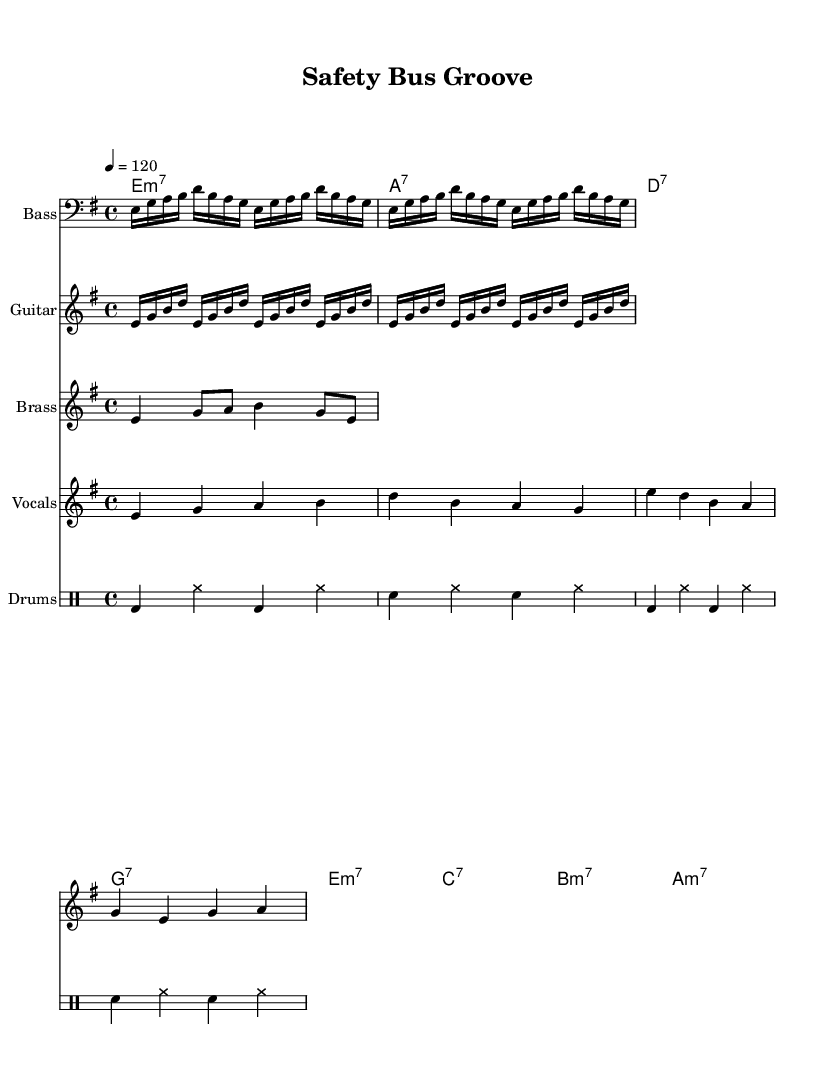What is the key signature of this music? The key signature is E minor, which has one sharp (F#). This can be identified by looking at the key signature indication at the beginning of the score.
Answer: E minor What is the time signature of the piece? The time signature is 4/4, meaning there are four beats in each measure and a quarter note receives one beat. This is indicated at the start of the score in a typical time signature notation.
Answer: 4/4 What is the tempo marking for this piece? The tempo marking is 120 beats per minute, which indicates how fast the music should be played. It can be found near the beginning of the score, specifically under the word "tempo."
Answer: 120 How many measures are displayed for each section of instrumentation? Each section of instrumentation has four measures, which can be counted from the beginning of each instrument's staff and confirm each staff's length and content.
Answer: Four Which instrument features the brass melody? The brass melody is featured in the brass staff, where the notation specific to this instrumental section is shown. This can be visually confirmed by identifying which staff includes the labeled title "Brass."
Answer: Brass What chords are used in the progression? The chord progression utilized in this piece includes E minor 7, A 7, D 7, and G 7, which can be identified from the ChordNames staff at the beginning where the chords are explicitly written.
Answer: E minor 7, A 7, D 7, G 7 What type of rhythm pattern do the drums use? The drum rhythm pattern consists of bass drum and snare hits alternated with hi-hat, creating a consistent funk groove. This can be observed in the drummode section of the score, where specific drum notations are laid out.
Answer: Funk groove 